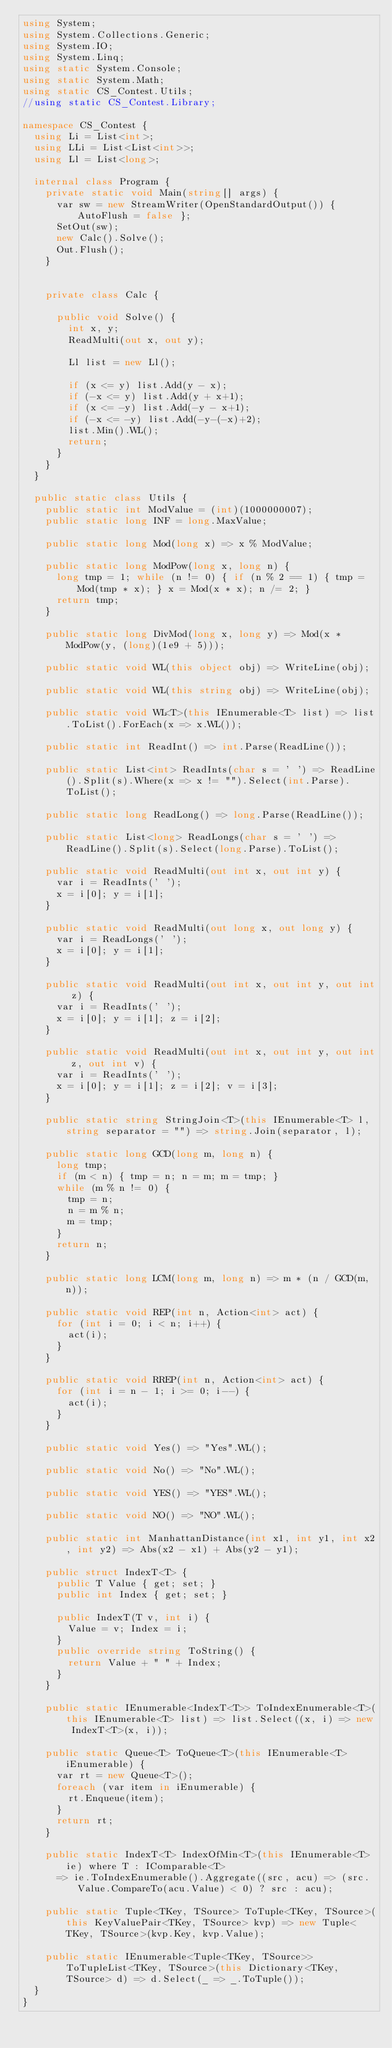Convert code to text. <code><loc_0><loc_0><loc_500><loc_500><_C#_>using System;
using System.Collections.Generic;
using System.IO;
using System.Linq;
using static System.Console;
using static System.Math;
using static CS_Contest.Utils;
//using static CS_Contest.Library;

namespace CS_Contest {
	using Li = List<int>;
	using LLi = List<List<int>>;
	using Ll = List<long>;

	internal class Program {
		private static void Main(string[] args) {
			var sw = new StreamWriter(OpenStandardOutput()) { AutoFlush = false };
			SetOut(sw);
			new Calc().Solve();
			Out.Flush();
		}
		

		private class Calc {

			public void Solve() {
				int x, y;
				ReadMulti(out x, out y);

				Ll list = new Ll();

				if (x <= y) list.Add(y - x);
				if (-x <= y) list.Add(y + x+1);
				if (x <= -y) list.Add(-y - x+1);
				if (-x <= -y) list.Add(-y-(-x)+2);
				list.Min().WL();
				return;
			}
		}
	}

	public static class Utils {
		public static int ModValue = (int)(1000000007);
		public static long INF = long.MaxValue;

		public static long Mod(long x) => x % ModValue;

		public static long ModPow(long x, long n) {
			long tmp = 1; while (n != 0) { if (n % 2 == 1) { tmp = Mod(tmp * x); } x = Mod(x * x); n /= 2; }
			return tmp;
		}

		public static long DivMod(long x, long y) => Mod(x * ModPow(y, (long)(1e9 + 5)));

		public static void WL(this object obj) => WriteLine(obj);

		public static void WL(this string obj) => WriteLine(obj);

		public static void WL<T>(this IEnumerable<T> list) => list.ToList().ForEach(x => x.WL());

		public static int ReadInt() => int.Parse(ReadLine());

		public static List<int> ReadInts(char s = ' ') => ReadLine().Split(s).Where(x => x != "").Select(int.Parse).ToList();

		public static long ReadLong() => long.Parse(ReadLine());

		public static List<long> ReadLongs(char s = ' ') => ReadLine().Split(s).Select(long.Parse).ToList();

		public static void ReadMulti(out int x, out int y) {
			var i = ReadInts(' ');
			x = i[0]; y = i[1];
		}

		public static void ReadMulti(out long x, out long y) {
			var i = ReadLongs(' ');
			x = i[0]; y = i[1];
		}

		public static void ReadMulti(out int x, out int y, out int z) {
			var i = ReadInts(' ');
			x = i[0]; y = i[1]; z = i[2];
		}

		public static void ReadMulti(out int x, out int y, out int z, out int v) {
			var i = ReadInts(' ');
			x = i[0]; y = i[1]; z = i[2]; v = i[3];
		}

		public static string StringJoin<T>(this IEnumerable<T> l, string separator = "") => string.Join(separator, l);

		public static long GCD(long m, long n) {
			long tmp;
			if (m < n) { tmp = n; n = m; m = tmp; }
			while (m % n != 0) {
				tmp = n;
				n = m % n;
				m = tmp;
			}
			return n;
		}

		public static long LCM(long m, long n) => m * (n / GCD(m, n));

		public static void REP(int n, Action<int> act) {
			for (int i = 0; i < n; i++) {
				act(i);
			}
		}

		public static void RREP(int n, Action<int> act) {
			for (int i = n - 1; i >= 0; i--) {
				act(i);
			}
		}

		public static void Yes() => "Yes".WL();

		public static void No() => "No".WL();

		public static void YES() => "YES".WL();

		public static void NO() => "NO".WL();

		public static int ManhattanDistance(int x1, int y1, int x2, int y2) => Abs(x2 - x1) + Abs(y2 - y1);

		public struct IndexT<T> {
			public T Value { get; set; }
			public int Index { get; set; }

			public IndexT(T v, int i) {
				Value = v; Index = i;
			}
			public override string ToString() {
				return Value + " " + Index;
			}
		}

		public static IEnumerable<IndexT<T>> ToIndexEnumerable<T>(this IEnumerable<T> list) => list.Select((x, i) => new IndexT<T>(x, i));

		public static Queue<T> ToQueue<T>(this IEnumerable<T> iEnumerable) {
			var rt = new Queue<T>();
			foreach (var item in iEnumerable) {
				rt.Enqueue(item);
			}
			return rt;
		}

		public static IndexT<T> IndexOfMin<T>(this IEnumerable<T> ie) where T : IComparable<T>
			=> ie.ToIndexEnumerable().Aggregate((src, acu) => (src.Value.CompareTo(acu.Value) < 0) ? src : acu);

		public static Tuple<TKey, TSource> ToTuple<TKey, TSource>(this KeyValuePair<TKey, TSource> kvp) => new Tuple<TKey, TSource>(kvp.Key, kvp.Value);

		public static IEnumerable<Tuple<TKey, TSource>> ToTupleList<TKey, TSource>(this Dictionary<TKey, TSource> d) => d.Select(_ => _.ToTuple());
	}
}</code> 